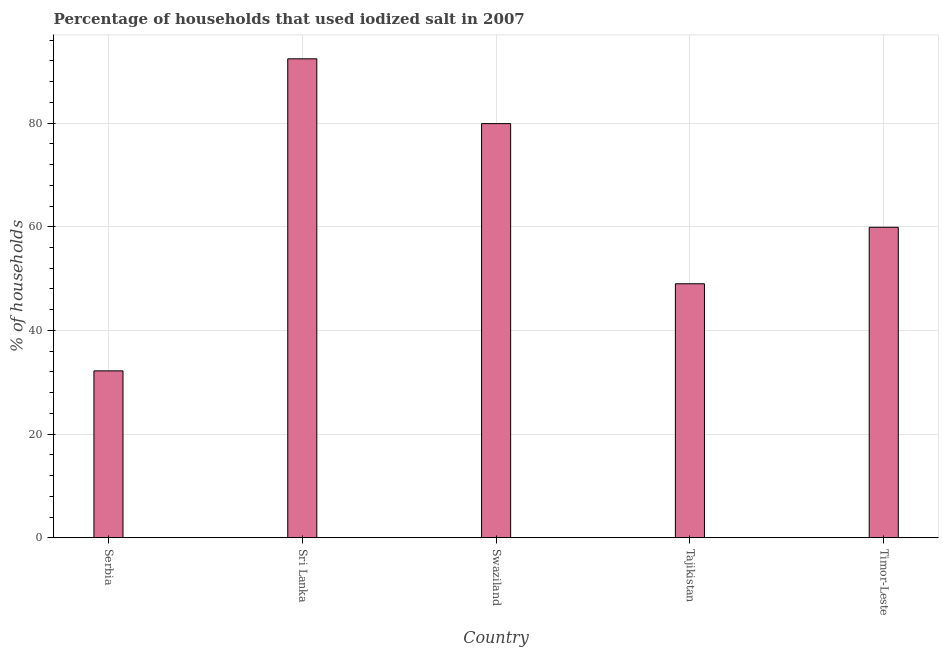What is the title of the graph?
Make the answer very short. Percentage of households that used iodized salt in 2007. What is the label or title of the X-axis?
Your answer should be very brief. Country. What is the label or title of the Y-axis?
Keep it short and to the point. % of households. Across all countries, what is the maximum percentage of households where iodized salt is consumed?
Your response must be concise. 92.4. Across all countries, what is the minimum percentage of households where iodized salt is consumed?
Make the answer very short. 32.2. In which country was the percentage of households where iodized salt is consumed maximum?
Offer a very short reply. Sri Lanka. In which country was the percentage of households where iodized salt is consumed minimum?
Provide a succinct answer. Serbia. What is the sum of the percentage of households where iodized salt is consumed?
Your answer should be compact. 313.4. What is the difference between the percentage of households where iodized salt is consumed in Swaziland and Timor-Leste?
Offer a terse response. 20. What is the average percentage of households where iodized salt is consumed per country?
Provide a succinct answer. 62.68. What is the median percentage of households where iodized salt is consumed?
Your answer should be compact. 59.9. In how many countries, is the percentage of households where iodized salt is consumed greater than 72 %?
Your answer should be very brief. 2. What is the ratio of the percentage of households where iodized salt is consumed in Swaziland to that in Timor-Leste?
Provide a short and direct response. 1.33. Is the difference between the percentage of households where iodized salt is consumed in Serbia and Timor-Leste greater than the difference between any two countries?
Your response must be concise. No. What is the difference between the highest and the lowest percentage of households where iodized salt is consumed?
Your answer should be compact. 60.2. In how many countries, is the percentage of households where iodized salt is consumed greater than the average percentage of households where iodized salt is consumed taken over all countries?
Provide a succinct answer. 2. Are the values on the major ticks of Y-axis written in scientific E-notation?
Offer a terse response. No. What is the % of households of Serbia?
Provide a succinct answer. 32.2. What is the % of households in Sri Lanka?
Provide a short and direct response. 92.4. What is the % of households of Swaziland?
Keep it short and to the point. 79.9. What is the % of households of Timor-Leste?
Offer a terse response. 59.9. What is the difference between the % of households in Serbia and Sri Lanka?
Keep it short and to the point. -60.2. What is the difference between the % of households in Serbia and Swaziland?
Ensure brevity in your answer.  -47.7. What is the difference between the % of households in Serbia and Tajikistan?
Offer a very short reply. -16.8. What is the difference between the % of households in Serbia and Timor-Leste?
Keep it short and to the point. -27.7. What is the difference between the % of households in Sri Lanka and Swaziland?
Offer a very short reply. 12.5. What is the difference between the % of households in Sri Lanka and Tajikistan?
Offer a terse response. 43.4. What is the difference between the % of households in Sri Lanka and Timor-Leste?
Your response must be concise. 32.5. What is the difference between the % of households in Swaziland and Tajikistan?
Your response must be concise. 30.9. What is the difference between the % of households in Tajikistan and Timor-Leste?
Offer a very short reply. -10.9. What is the ratio of the % of households in Serbia to that in Sri Lanka?
Provide a succinct answer. 0.35. What is the ratio of the % of households in Serbia to that in Swaziland?
Keep it short and to the point. 0.4. What is the ratio of the % of households in Serbia to that in Tajikistan?
Offer a terse response. 0.66. What is the ratio of the % of households in Serbia to that in Timor-Leste?
Keep it short and to the point. 0.54. What is the ratio of the % of households in Sri Lanka to that in Swaziland?
Ensure brevity in your answer.  1.16. What is the ratio of the % of households in Sri Lanka to that in Tajikistan?
Your answer should be very brief. 1.89. What is the ratio of the % of households in Sri Lanka to that in Timor-Leste?
Offer a terse response. 1.54. What is the ratio of the % of households in Swaziland to that in Tajikistan?
Provide a succinct answer. 1.63. What is the ratio of the % of households in Swaziland to that in Timor-Leste?
Offer a terse response. 1.33. What is the ratio of the % of households in Tajikistan to that in Timor-Leste?
Offer a very short reply. 0.82. 